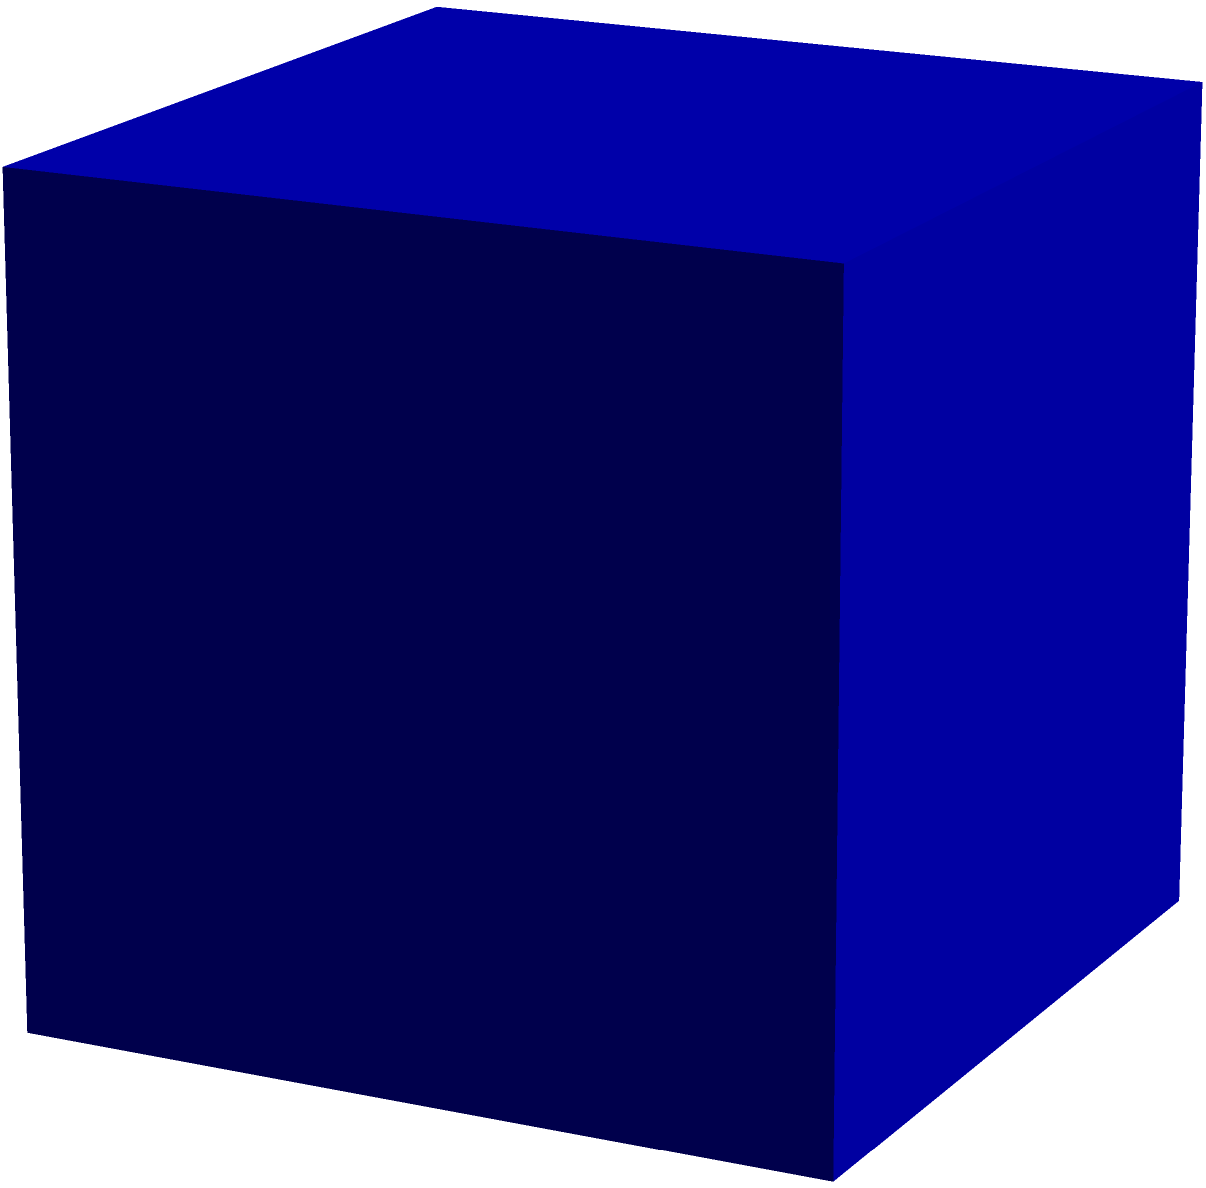Calculate the surface area of a mirrored cube with edge length $a$, used in a classic misdirection technique. How does this area relate to the cube's ability to create illusions? To calculate the surface area of a mirrored cube:

1. Identify the shape: A cube has 6 identical square faces.

2. Calculate the area of one face:
   Area of one face = $a^2$

3. Multiply by the number of faces:
   Total surface area = $6 * a^2$

4. Therefore, the surface area formula is:
   $S = 6a^2$

The larger the surface area, the more reflective surfaces are available for creating illusions. This increases the magician's ability to manipulate the audience's perception through misdirection techniques.

The mirrored surfaces can:
- Create false depths
- Reflect light in unexpected ways
- Hide or reveal objects strategically

A larger cube provides more options for complex illusions, but may be harder to conceal or manipulate discreetly.
Answer: $6a^2$ 